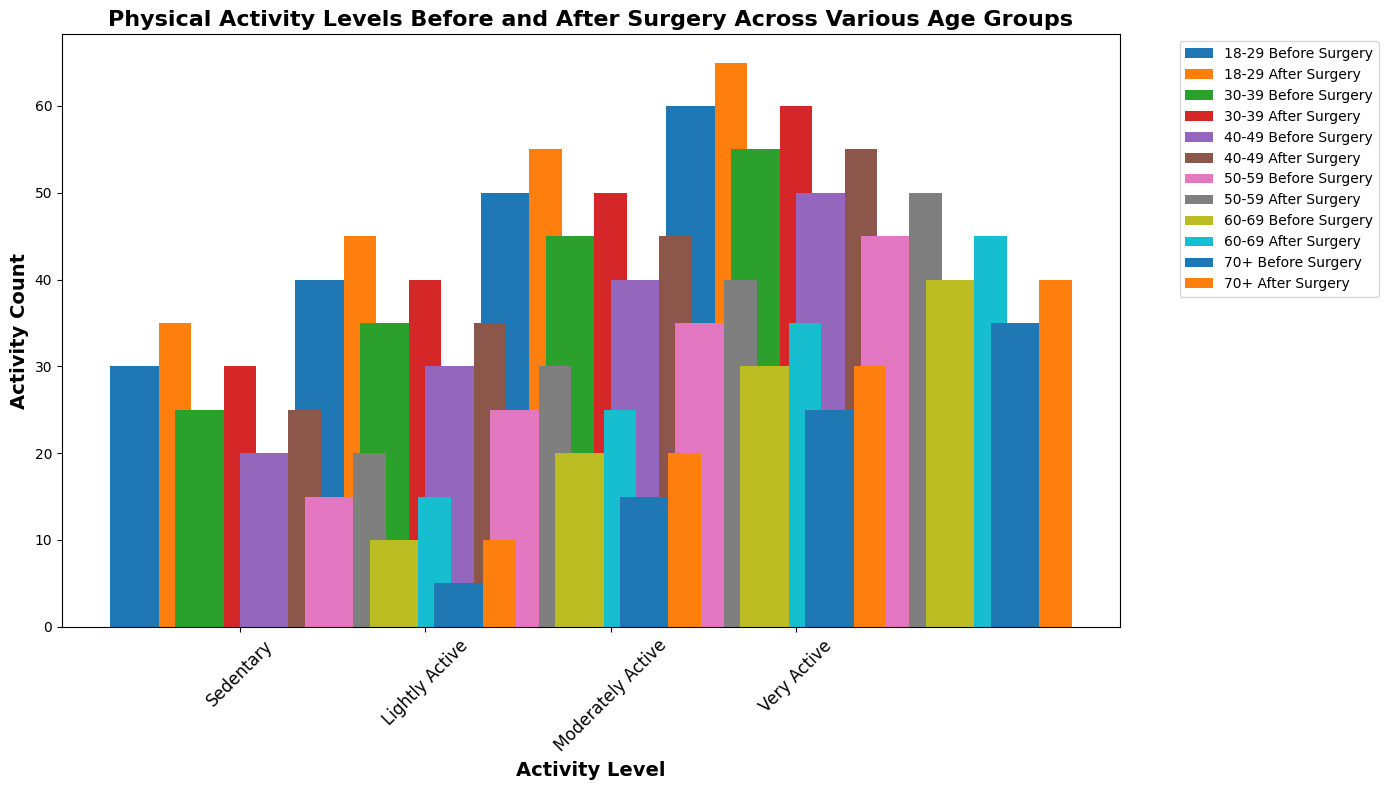What is the trend in sedentary activity levels before and after surgery across different age groups? To find the trend, we observe the heights of the bars for sedentary activity levels for each age group before and after surgery. Each bar pair increases from before to after surgery across all age groups.
Answer: Increasing Which age group has the highest number of people who are very active after surgery? Look at the bars labeled "Very Active" and identify the highest bar for the "After Surgery" set. The age group "18-29" has the tallest "Very Active" bar.
Answer: 18-29 How does the number of lightly active individuals in the 60-69 age group compare before and after surgery? Compare the heights of the "Lightly Active" bars for the 60-69 age group before and after surgery. The after-surgery bar is taller than the before-surgery bar.
Answer: Increased What is the total count of moderately active individuals in the 40-49 age group before and after surgery combined? Add the counts of moderately active individuals before surgery (40) and after surgery (45) for the 40-49 age group.
Answer: 85 Which age group shows the smallest improvement in sedentary activity levels after surgery? For each age group, subtract the "Before Surgery" sedentary count from the "After Surgery" sedentary count. The age group "18-29" has the smallest difference (35-30 = 5).
Answer: 18-29 Are there any age groups where the level of lightly active individuals did not change after surgery? Check for equality between "Before Surgery" and "After Surgery" counts for lightly active levels in each age group. All age groups show some change in lightly active levels.
Answer: No Which age group has the highest variation between before and after surgery levels in any activity category? Calculate the differences between before and after surgery for each activity category and find the largest difference. The "Moderately Active" category in the age group "70+" has the highest variation (30 - 25 = 5).
Answer: 70+ For the age group 30-39, what is the percentage increase in very active individuals after surgery? Calculate the percentage change from before (55) to after (60) surgery. The percentage increase is ((60-55)/55) * 100.
Answer: 9.09% Which activity level category shows the most consistent improvement across all age groups? Look for the activity level with the smallest range of differences between before and after surgery across all age groups. "Sedentary" shows the smallest range in increased counts through all age groups.
Answer: Sedentary What is the total number of individuals who were sedentary before surgery in all age groups? Sum the counts of individuals who were sedentary before surgery across all age groups: 30 + 25 + 20 + 15 + 10 + 5 = 105.
Answer: 105 